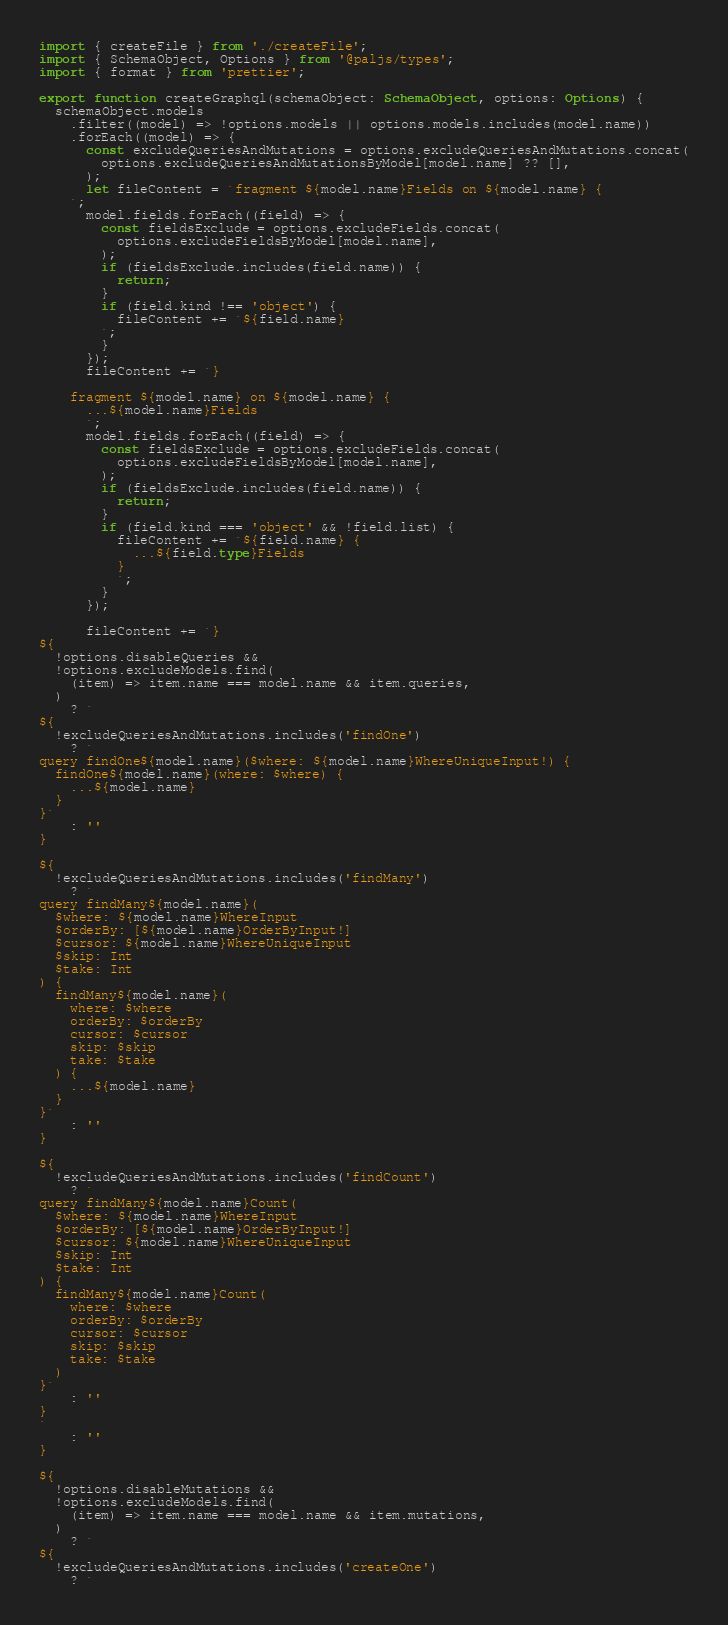Convert code to text. <code><loc_0><loc_0><loc_500><loc_500><_TypeScript_>import { createFile } from './createFile';
import { SchemaObject, Options } from '@paljs/types';
import { format } from 'prettier';

export function createGraphql(schemaObject: SchemaObject, options: Options) {
  schemaObject.models
    .filter((model) => !options.models || options.models.includes(model.name))
    .forEach((model) => {
      const excludeQueriesAndMutations = options.excludeQueriesAndMutations.concat(
        options.excludeQueriesAndMutationsByModel[model.name] ?? [],
      );
      let fileContent = `fragment ${model.name}Fields on ${model.name} {
    `;
      model.fields.forEach((field) => {
        const fieldsExclude = options.excludeFields.concat(
          options.excludeFieldsByModel[model.name],
        );
        if (fieldsExclude.includes(field.name)) {
          return;
        }
        if (field.kind !== 'object') {
          fileContent += `${field.name}
        `;
        }
      });
      fileContent += `}
    
    fragment ${model.name} on ${model.name} {
      ...${model.name}Fields
      `;
      model.fields.forEach((field) => {
        const fieldsExclude = options.excludeFields.concat(
          options.excludeFieldsByModel[model.name],
        );
        if (fieldsExclude.includes(field.name)) {
          return;
        }
        if (field.kind === 'object' && !field.list) {
          fileContent += `${field.name} {
            ...${field.type}Fields
          }
          `;
        }
      });

      fileContent += `}
${
  !options.disableQueries &&
  !options.excludeModels.find(
    (item) => item.name === model.name && item.queries,
  )
    ? `
${
  !excludeQueriesAndMutations.includes('findOne')
    ? `
query findOne${model.name}($where: ${model.name}WhereUniqueInput!) {
  findOne${model.name}(where: $where) {
    ...${model.name}
  }
}`
    : ''
}    

${
  !excludeQueriesAndMutations.includes('findMany')
    ? `
query findMany${model.name}(
  $where: ${model.name}WhereInput
  $orderBy: [${model.name}OrderByInput!]
  $cursor: ${model.name}WhereUniqueInput
  $skip: Int
  $take: Int
) {
  findMany${model.name}(
    where: $where
    orderBy: $orderBy
    cursor: $cursor
    skip: $skip
    take: $take
  ) {
    ...${model.name}
  }
}`
    : ''
}  

${
  !excludeQueriesAndMutations.includes('findCount')
    ? `
query findMany${model.name}Count(
  $where: ${model.name}WhereInput
  $orderBy: [${model.name}OrderByInput!]
  $cursor: ${model.name}WhereUniqueInput
  $skip: Int
  $take: Int
) {
  findMany${model.name}Count(
    where: $where
    orderBy: $orderBy
    cursor: $cursor
    skip: $skip
    take: $take
  )
}`
    : ''
}  
`
    : ''
}

${
  !options.disableMutations &&
  !options.excludeModels.find(
    (item) => item.name === model.name && item.mutations,
  )
    ? `
${
  !excludeQueriesAndMutations.includes('createOne')
    ? `</code> 